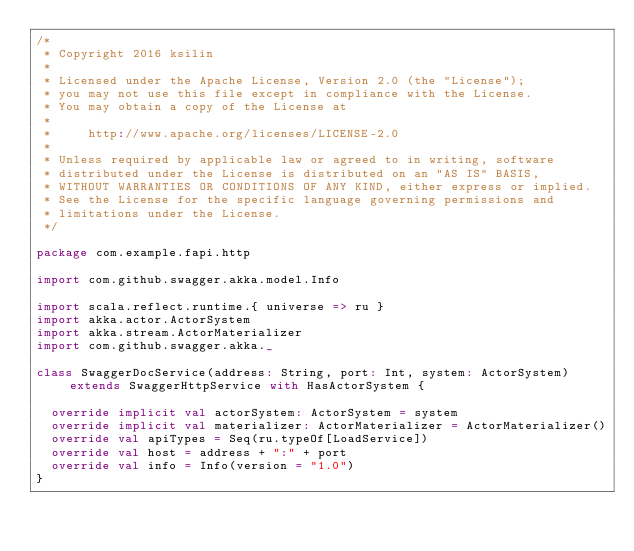<code> <loc_0><loc_0><loc_500><loc_500><_Scala_>/*
 * Copyright 2016 ksilin
 *
 * Licensed under the Apache License, Version 2.0 (the "License");
 * you may not use this file except in compliance with the License.
 * You may obtain a copy of the License at
 *
 *     http://www.apache.org/licenses/LICENSE-2.0
 *
 * Unless required by applicable law or agreed to in writing, software
 * distributed under the License is distributed on an "AS IS" BASIS,
 * WITHOUT WARRANTIES OR CONDITIONS OF ANY KIND, either express or implied.
 * See the License for the specific language governing permissions and
 * limitations under the License.
 */

package com.example.fapi.http

import com.github.swagger.akka.model.Info

import scala.reflect.runtime.{ universe => ru }
import akka.actor.ActorSystem
import akka.stream.ActorMaterializer
import com.github.swagger.akka._

class SwaggerDocService(address: String, port: Int, system: ActorSystem) extends SwaggerHttpService with HasActorSystem {

  override implicit val actorSystem: ActorSystem = system
  override implicit val materializer: ActorMaterializer = ActorMaterializer()
  override val apiTypes = Seq(ru.typeOf[LoadService])
  override val host = address + ":" + port
  override val info = Info(version = "1.0")
}
</code> 